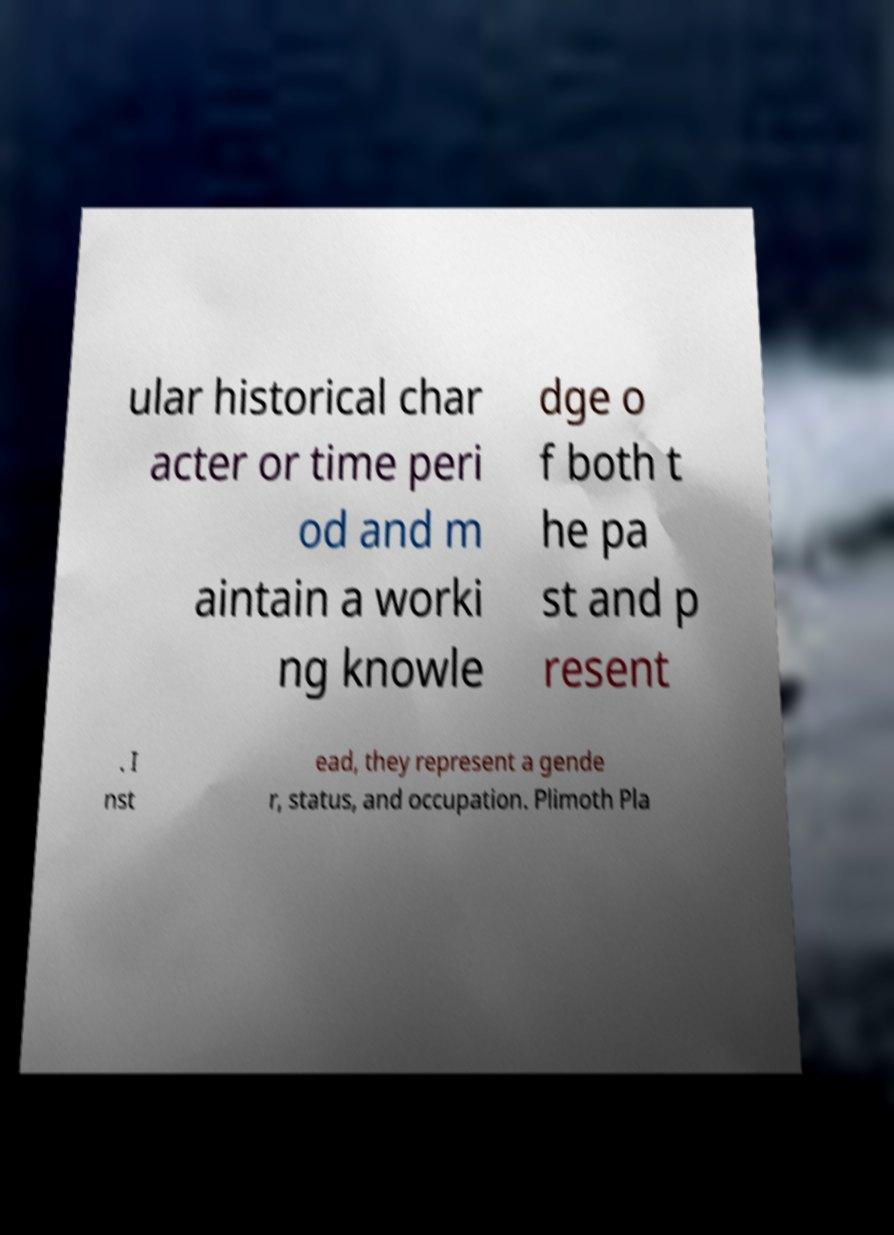Could you assist in decoding the text presented in this image and type it out clearly? ular historical char acter or time peri od and m aintain a worki ng knowle dge o f both t he pa st and p resent . I nst ead, they represent a gende r, status, and occupation. Plimoth Pla 